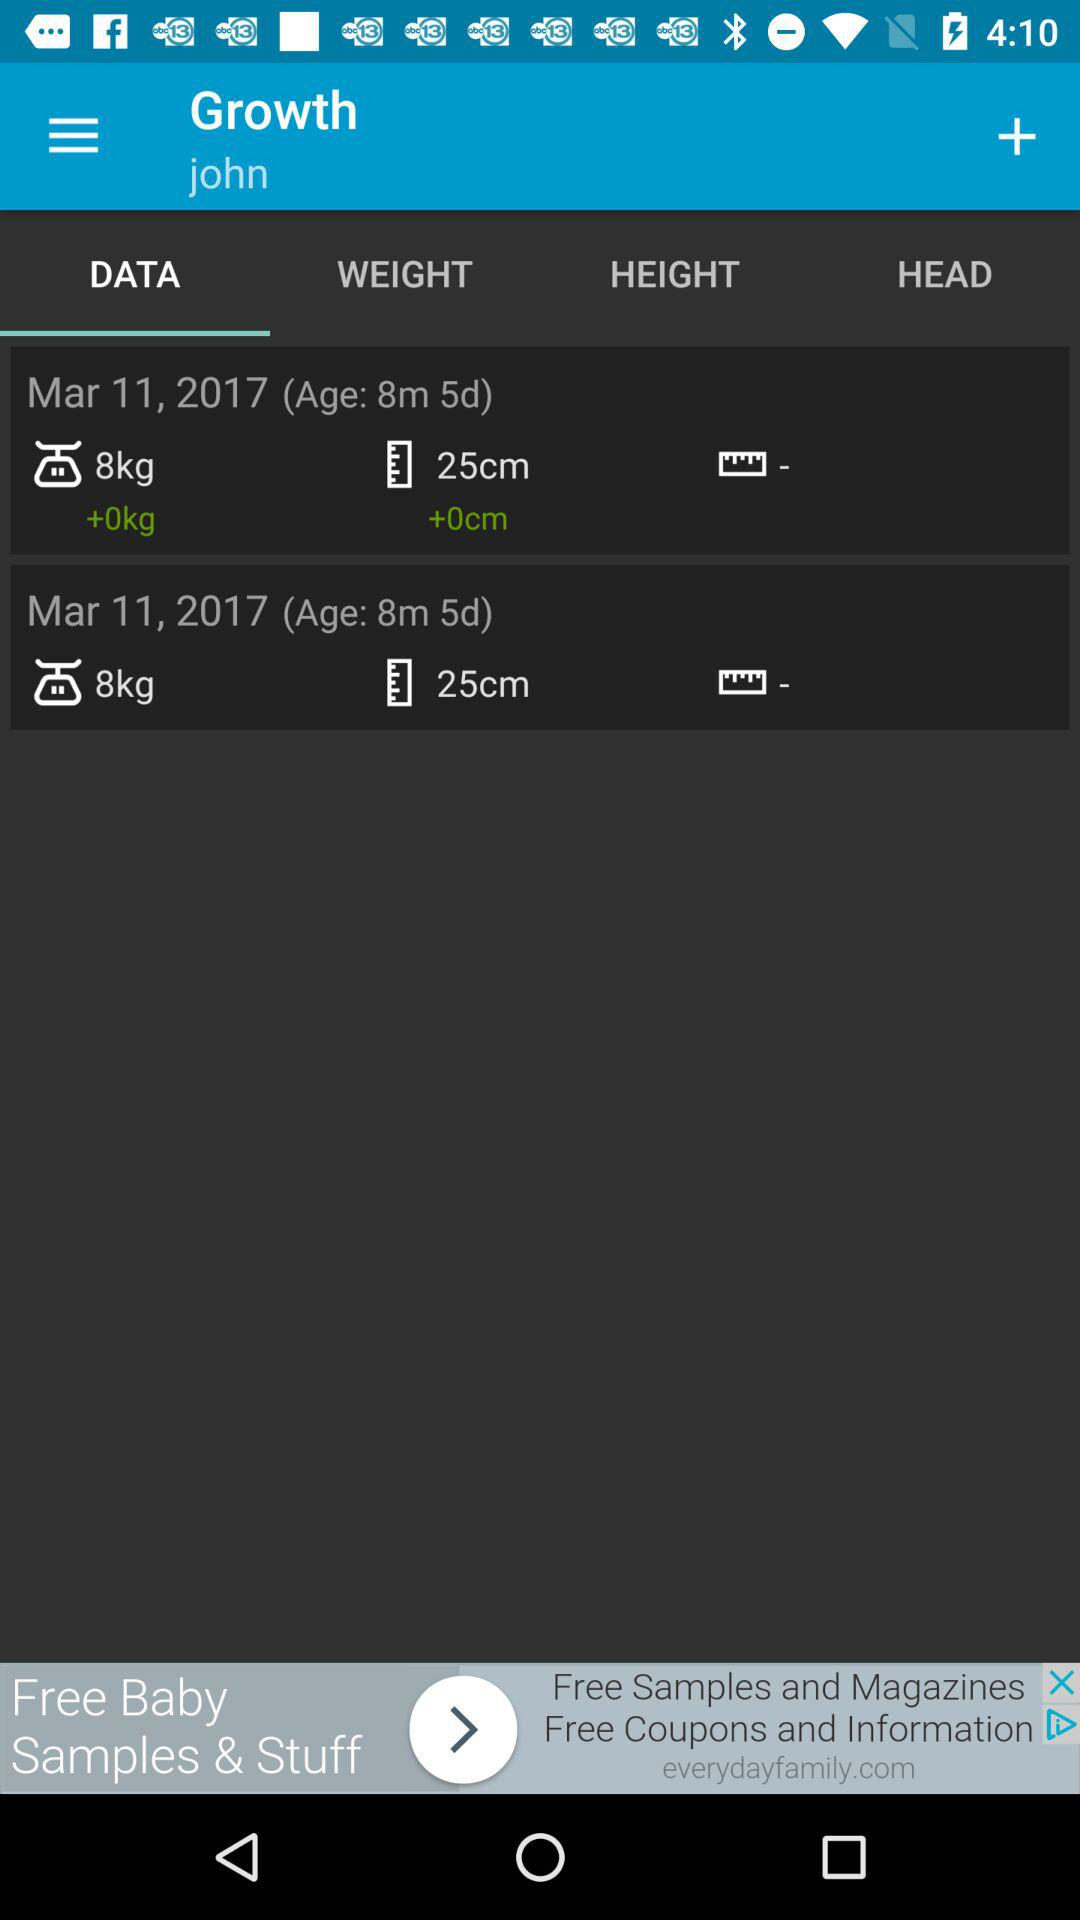What is the age of John on March 11, 2017? The age is 8 months and 5 days. 